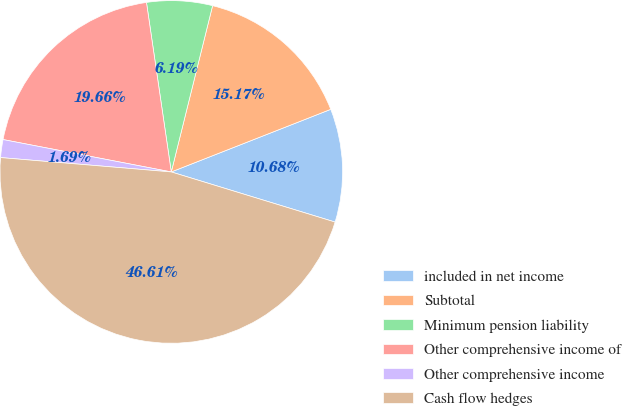Convert chart. <chart><loc_0><loc_0><loc_500><loc_500><pie_chart><fcel>included in net income<fcel>Subtotal<fcel>Minimum pension liability<fcel>Other comprehensive income of<fcel>Other comprehensive income<fcel>Cash flow hedges<nl><fcel>10.68%<fcel>15.17%<fcel>6.19%<fcel>19.66%<fcel>1.69%<fcel>46.61%<nl></chart> 